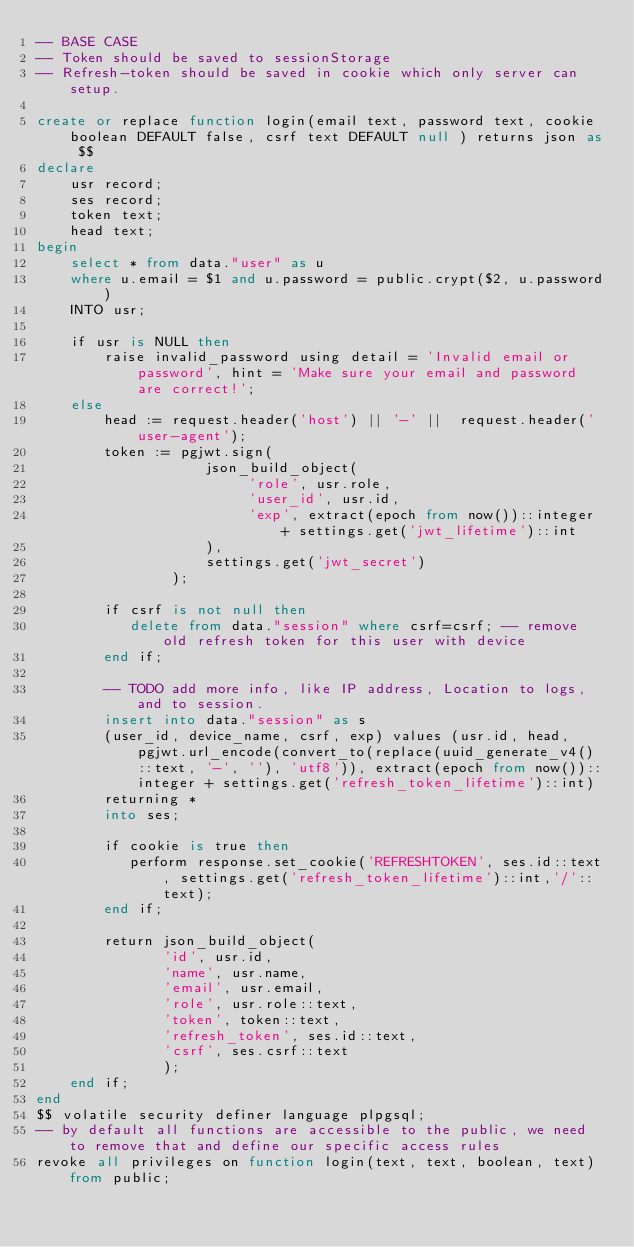<code> <loc_0><loc_0><loc_500><loc_500><_SQL_>-- BASE CASE
-- Token should be saved to sessionStorage
-- Refresh-token should be saved in cookie which only server can setup.

create or replace function login(email text, password text, cookie boolean DEFAULT false, csrf text DEFAULT null ) returns json as $$
declare
    usr record;
    ses record;
    token text;
    head text;
begin
    select * from data."user" as u
    where u.email = $1 and u.password = public.crypt($2, u.password)
    INTO usr;

    if usr is NULL then
        raise invalid_password using detail = 'Invalid email or password', hint = 'Make sure your email and password are correct!';
    else
        head := request.header('host') || '-' ||  request.header('user-agent');
        token := pgjwt.sign(
                    json_build_object(
                         'role', usr.role,
                         'user_id', usr.id,
                         'exp', extract(epoch from now())::integer + settings.get('jwt_lifetime')::int
                    ),
                    settings.get('jwt_secret')
                );

        if csrf is not null then
           delete from data."session" where csrf=csrf; -- remove old refresh token for this user with device
        end if;

        -- TODO add more info, like IP address, Location to logs, and to session.
        insert into data."session" as s
        (user_id, device_name, csrf, exp) values (usr.id, head, pgjwt.url_encode(convert_to(replace(uuid_generate_v4()::text, '-', ''), 'utf8')), extract(epoch from now())::integer + settings.get('refresh_token_lifetime')::int)
        returning *
        into ses;

        if cookie is true then
           perform response.set_cookie('REFRESHTOKEN', ses.id::text, settings.get('refresh_token_lifetime')::int,'/'::text);
        end if;

        return json_build_object(
               'id', usr.id,
               'name', usr.name,
               'email', usr.email,
               'role', usr.role::text,
               'token', token::text,
               'refresh_token', ses.id::text,
               'csrf', ses.csrf::text
               );
    end if;
end
$$ volatile security definer language plpgsql;
-- by default all functions are accessible to the public, we need to remove that and define our specific access rules
revoke all privileges on function login(text, text, boolean, text) from public;
</code> 